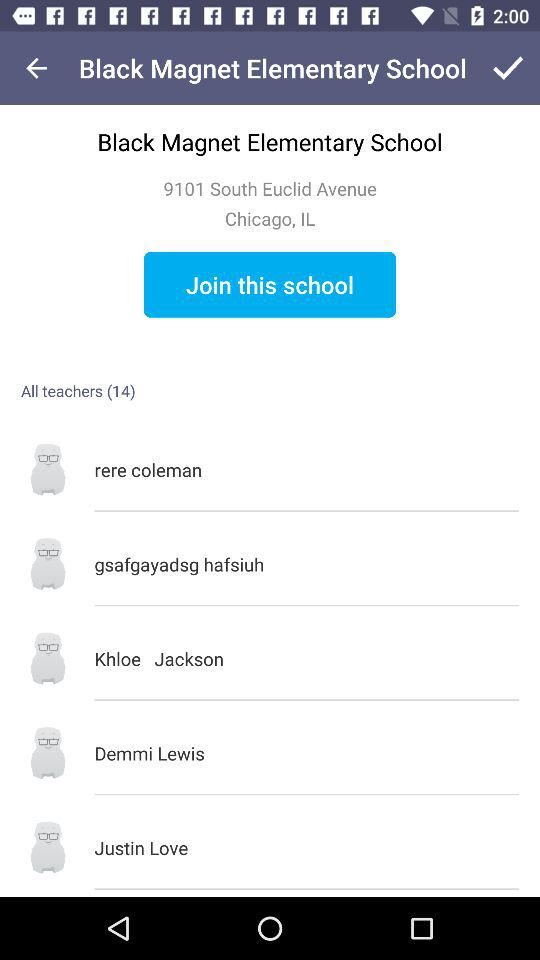How many total teachers are there? There are 14 total teachers. 